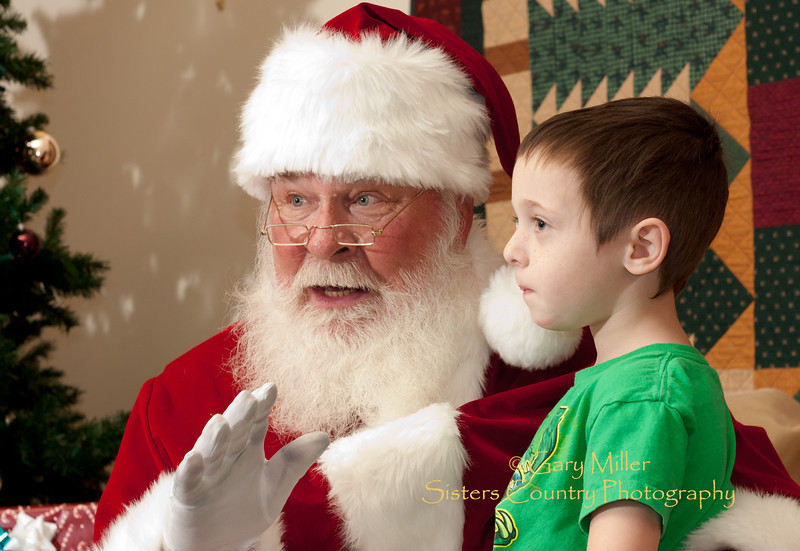Can you describe the interaction between the child and Santa and what it might say about their conversation? The interaction between the child and Santa appears to be one of deep engagement and mutual respect. Santa, using gentle hand gestures, seems to be either explaining something or narratively engrossing the child, who listens intently. The child's serious expression and focused attention suggest that Santa might be sharing an important or interesting Christmas story, possibly about the spirit of giving or a legendary holiday tale. This indicates a meaningful conversation that captivates the child's imagination and attention. 